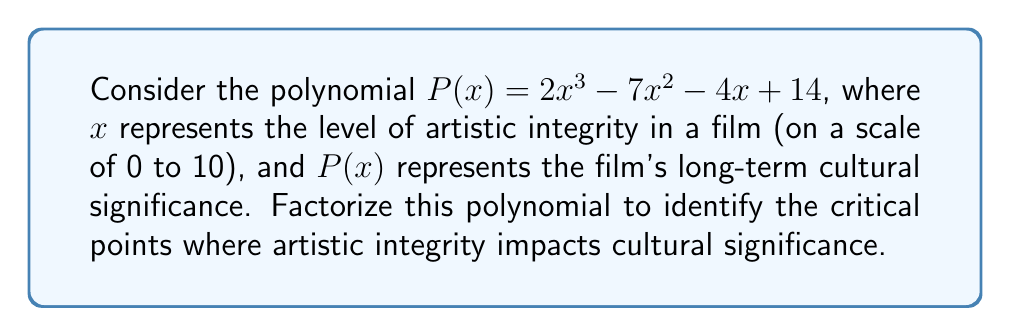Help me with this question. To factorize the polynomial $P(x) = 2x^3 - 7x^2 - 4x + 14$, we'll follow these steps:

1) First, let's check if there are any rational roots using the rational root theorem. The possible rational roots are the factors of the constant term (14): ±1, ±2, ±7, ±14.

2) Testing these values, we find that $x = 2$ is a root. So $(x - 2)$ is a factor.

3) Divide the polynomial by $(x - 2)$:

   $$\frac{2x^3 - 7x^2 - 4x + 14}{x - 2} = 2x^2 - 3x - 7$$

4) Now we have: $P(x) = (x - 2)(2x^2 - 3x - 7)$

5) For the quadratic factor $2x^2 - 3x - 7$, we can use the quadratic formula or factoring by grouping.

6) Using the quadratic formula: $x = \frac{3 \pm \sqrt{9 + 56}}{4} = \frac{3 \pm \sqrt{65}}{4}$

7) Therefore, the complete factorization is:

   $$P(x) = (x - 2)(2x - \frac{3 + \sqrt{65}}{2})(2x - \frac{3 - \sqrt{65}}{2})$$

This factorization reveals the critical points where artistic integrity ($x$) significantly impacts cultural significance: at $x = 2$, and at the two irrational roots $x = \frac{3 + \sqrt{65}}{4}$ and $x = \frac{3 - \sqrt{65}}{4}$.
Answer: $$(x - 2)(2x - \frac{3 + \sqrt{65}}{2})(2x - \frac{3 - \sqrt{65}}{2})$$ 